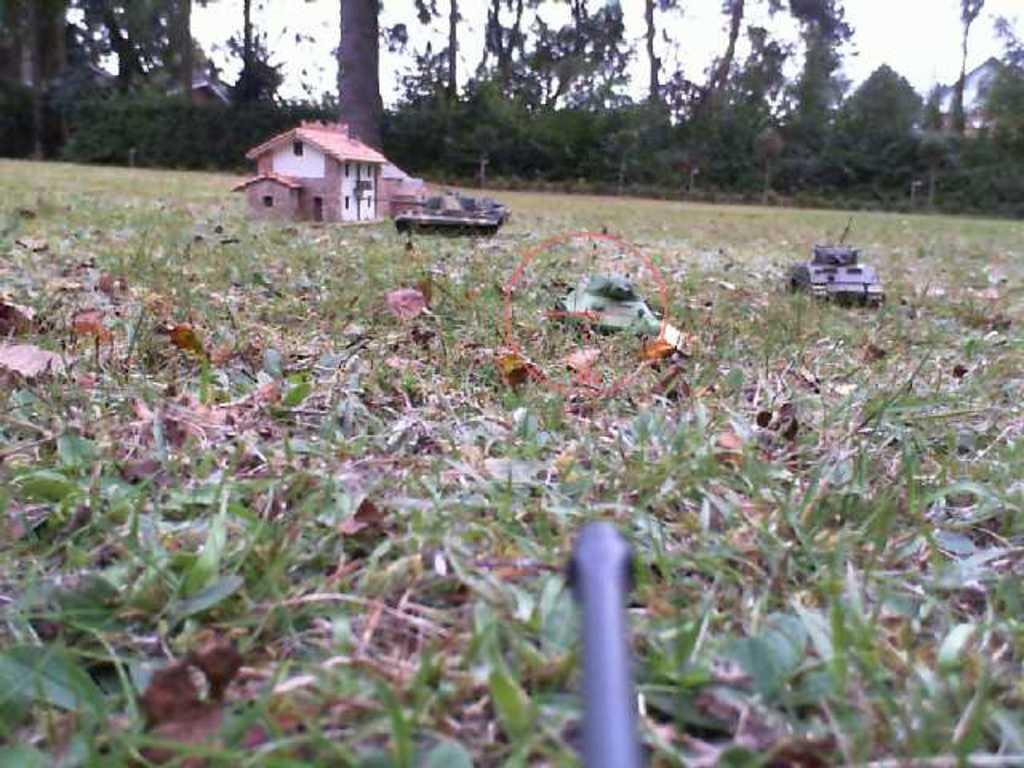In one or two sentences, can you explain what this image depicts? In this image, we can see the ground covered with grass and some dried leaves. We can see some toys and also an object at the bottom. We can see some trees, plants and houses. We can also see the sky. 